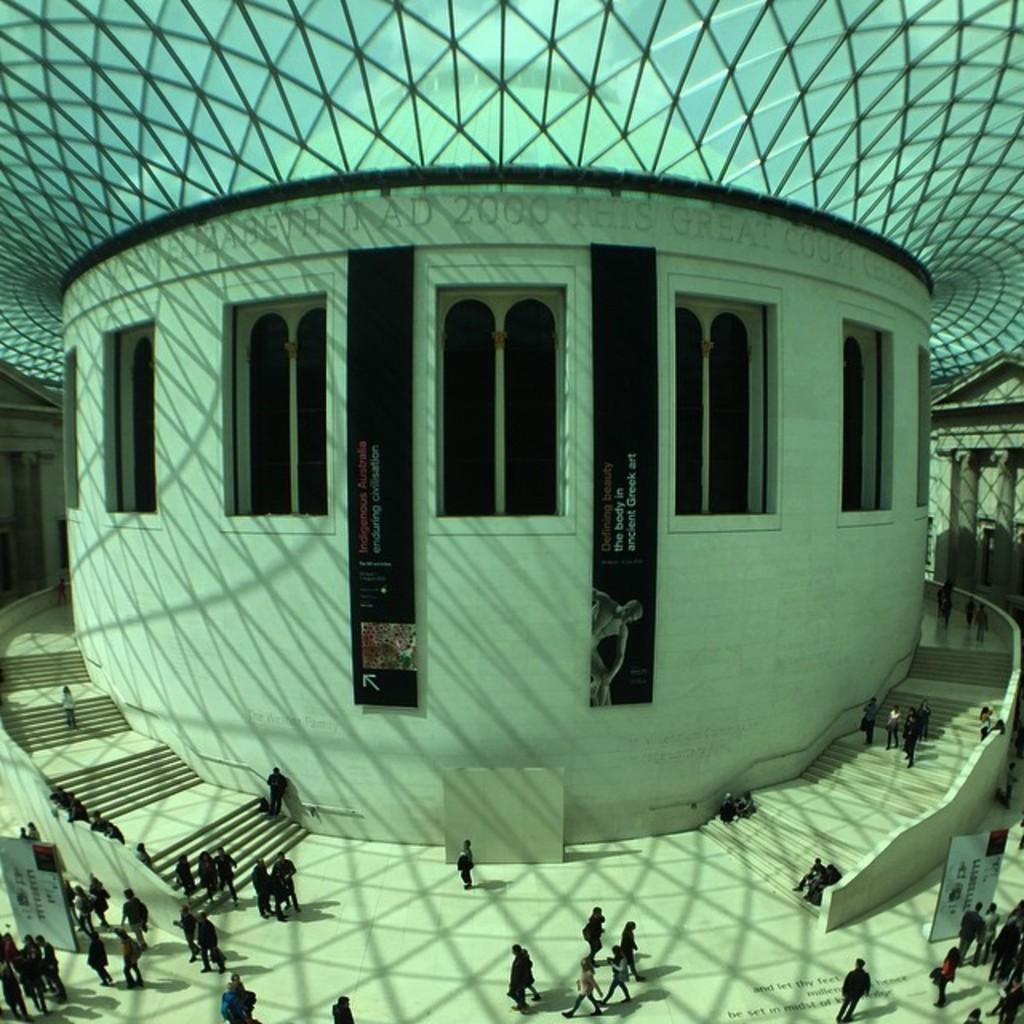Please provide a concise description of this image. In this picture we can see a building. There are a few boards on the path. We can see black color posters. There is a text on the floor. 